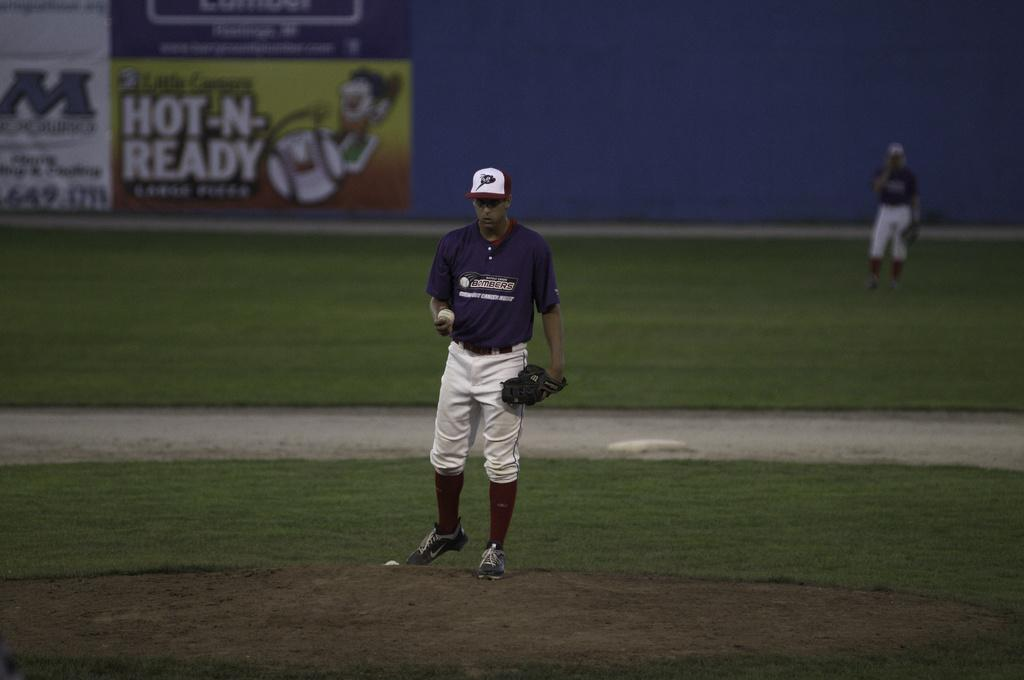Provide a one-sentence caption for the provided image. a Bombers player gets ready to pitch the ball. 